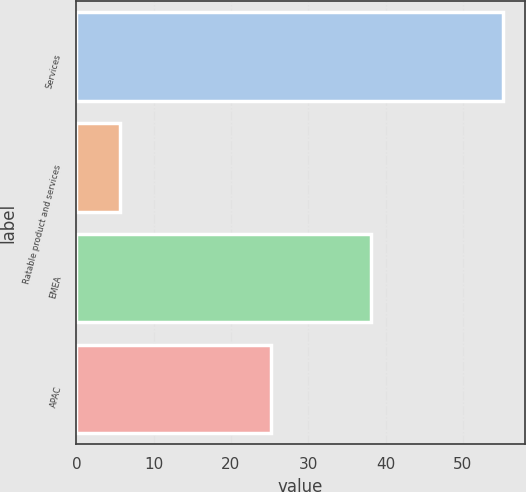<chart> <loc_0><loc_0><loc_500><loc_500><bar_chart><fcel>Services<fcel>Ratable product and services<fcel>EMEA<fcel>APAC<nl><fcel>55.2<fcel>5.7<fcel>38.1<fcel>25.2<nl></chart> 